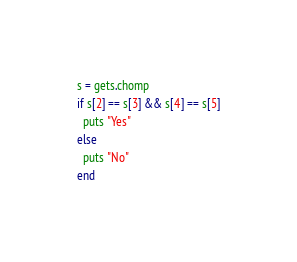<code> <loc_0><loc_0><loc_500><loc_500><_Ruby_>s = gets.chomp
if s[2] == s[3] && s[4] == s[5]
  puts "Yes"
else
  puts "No"
end</code> 